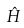Convert formula to latex. <formula><loc_0><loc_0><loc_500><loc_500>\hat { H }</formula> 